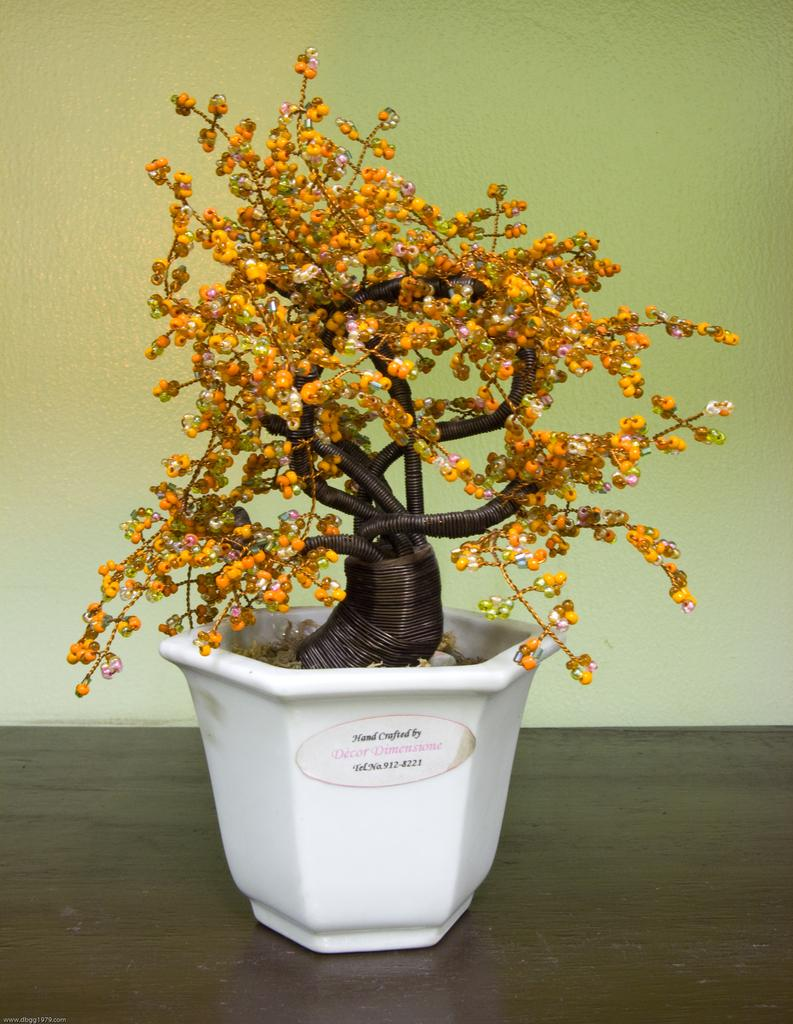What type of plant is in the image? There is a plastic plant in the image. Where is the plastic plant located? The plastic plant is in a pot. What is the pot resting on? The pot is on a platform. What can be seen around the plastic plant? There are objects around the plastic plant. What is visible in the background of the image? There is a wall in the background of the image. Which direction is the rabbit facing in the image? There is no rabbit present in the image. How many fingers can be seen on the person's hand in the image? There is no person or hand visible in the image. 